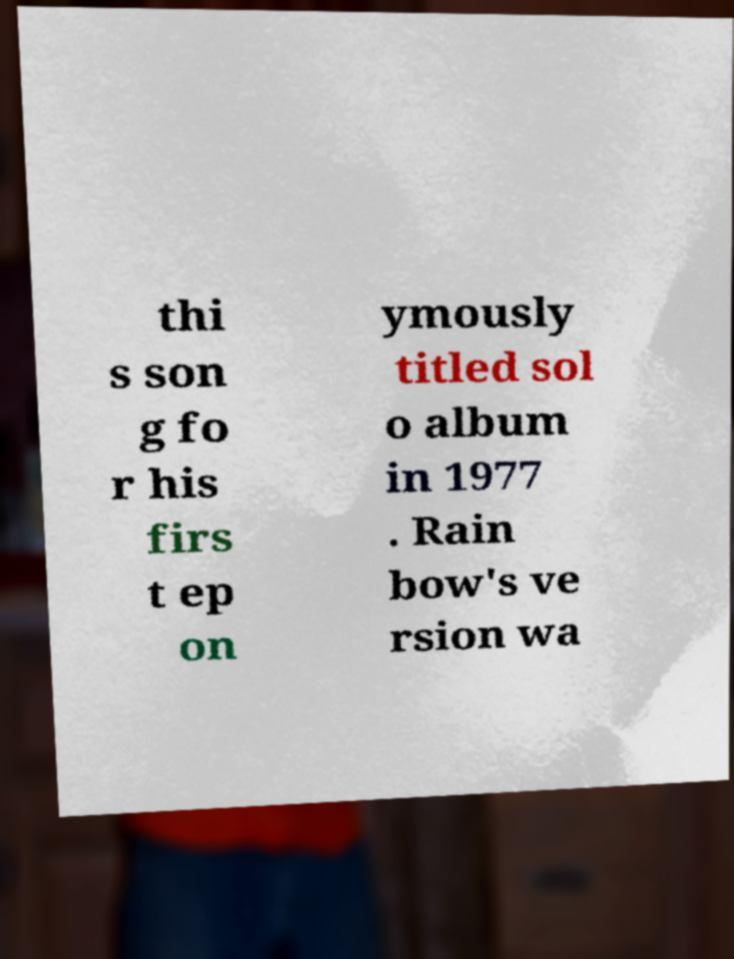Can you accurately transcribe the text from the provided image for me? thi s son g fo r his firs t ep on ymously titled sol o album in 1977 . Rain bow's ve rsion wa 